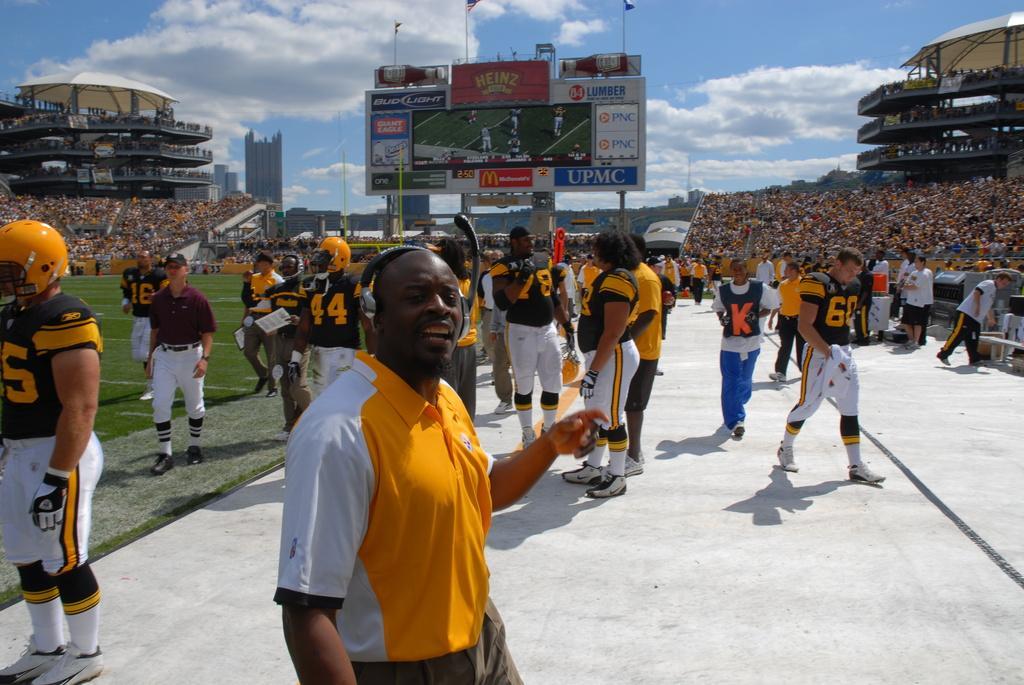In one or two sentences, can you explain what this image depicts? In the ground there are group of players walking around and there is a fencing around the ground. Behind the fencing there is crowd watching the match and in between the crowd there is a big led screen and around the screen there are banners of the sponsors. In the background there is a sky and clouds. 